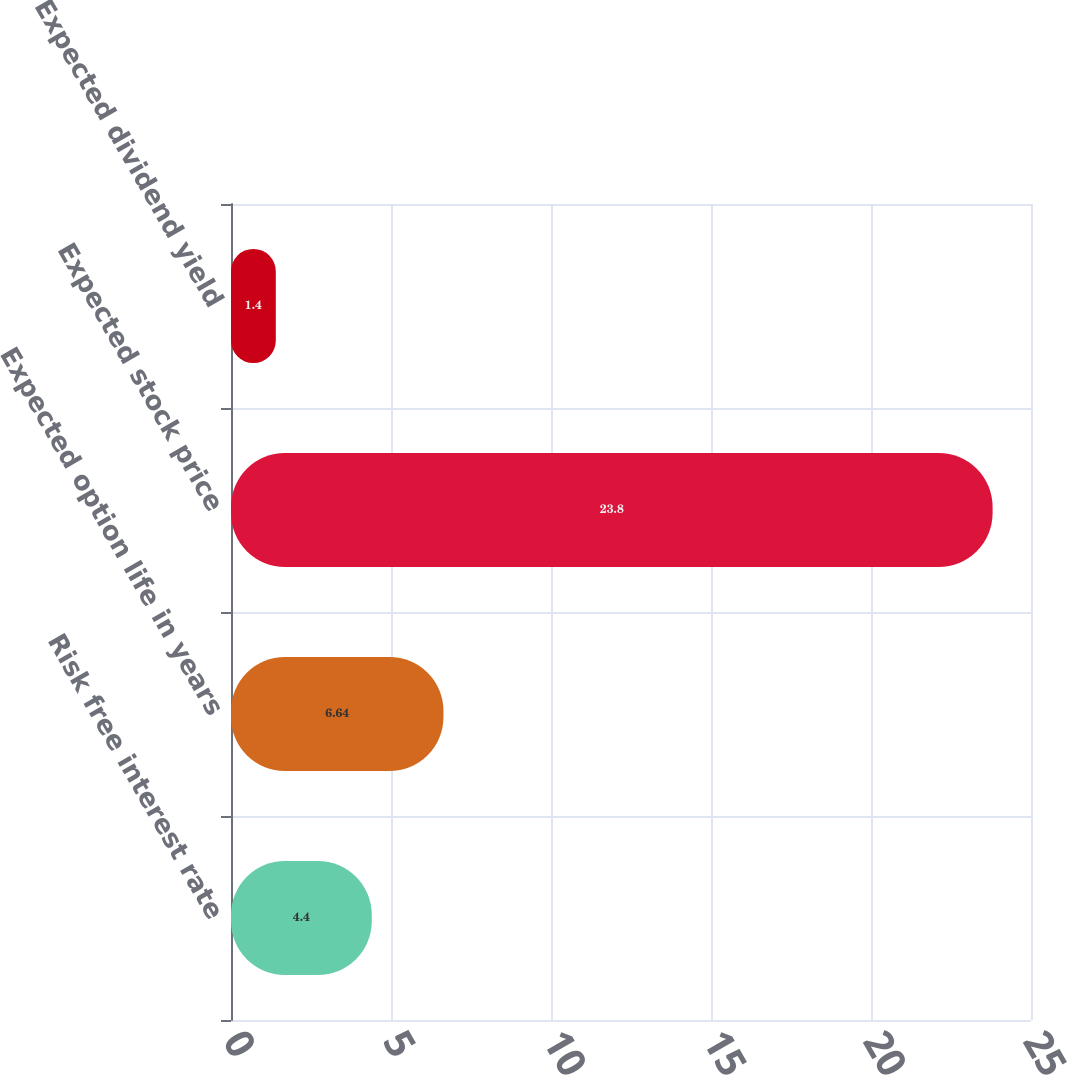Convert chart to OTSL. <chart><loc_0><loc_0><loc_500><loc_500><bar_chart><fcel>Risk free interest rate<fcel>Expected option life in years<fcel>Expected stock price<fcel>Expected dividend yield<nl><fcel>4.4<fcel>6.64<fcel>23.8<fcel>1.4<nl></chart> 